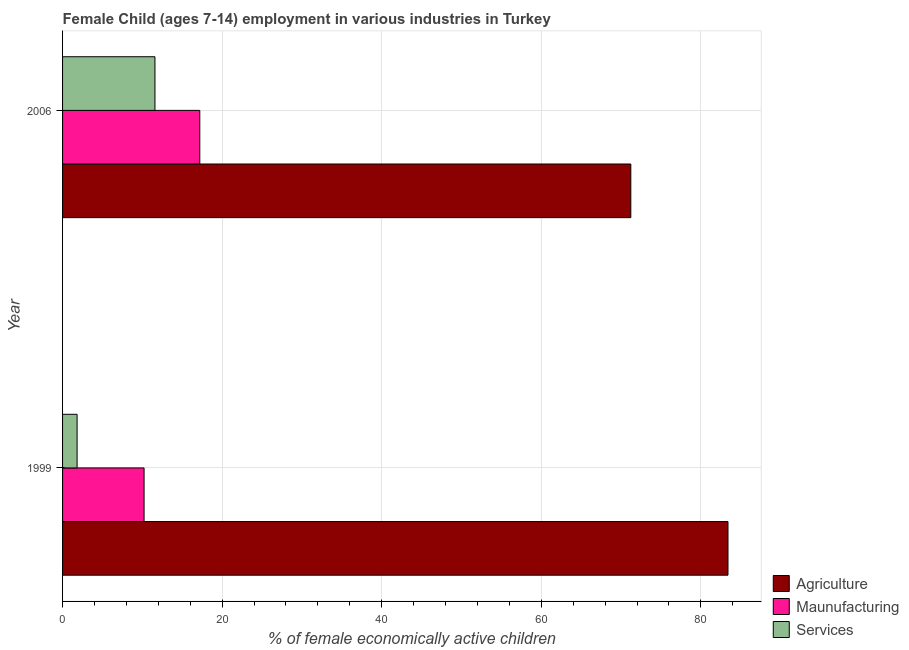How many groups of bars are there?
Provide a short and direct response. 2. Are the number of bars per tick equal to the number of legend labels?
Your answer should be very brief. Yes. In how many cases, is the number of bars for a given year not equal to the number of legend labels?
Your response must be concise. 0. What is the percentage of economically active children in manufacturing in 2006?
Offer a very short reply. 17.2. Across all years, what is the maximum percentage of economically active children in manufacturing?
Make the answer very short. 17.2. Across all years, what is the minimum percentage of economically active children in manufacturing?
Your answer should be compact. 10.22. In which year was the percentage of economically active children in services maximum?
Provide a succinct answer. 2006. In which year was the percentage of economically active children in services minimum?
Make the answer very short. 1999. What is the total percentage of economically active children in agriculture in the graph?
Give a very brief answer. 154.62. What is the difference between the percentage of economically active children in services in 1999 and that in 2006?
Your answer should be very brief. -9.76. What is the difference between the percentage of economically active children in services in 2006 and the percentage of economically active children in agriculture in 1999?
Your answer should be compact. -71.82. What is the average percentage of economically active children in agriculture per year?
Your response must be concise. 77.31. In the year 1999, what is the difference between the percentage of economically active children in services and percentage of economically active children in manufacturing?
Your answer should be very brief. -8.39. In how many years, is the percentage of economically active children in agriculture greater than 40 %?
Give a very brief answer. 2. What is the ratio of the percentage of economically active children in services in 1999 to that in 2006?
Your response must be concise. 0.16. Is the percentage of economically active children in agriculture in 1999 less than that in 2006?
Offer a very short reply. No. Is the difference between the percentage of economically active children in agriculture in 1999 and 2006 greater than the difference between the percentage of economically active children in manufacturing in 1999 and 2006?
Ensure brevity in your answer.  Yes. What does the 1st bar from the top in 1999 represents?
Offer a terse response. Services. What does the 1st bar from the bottom in 1999 represents?
Offer a terse response. Agriculture. How many bars are there?
Ensure brevity in your answer.  6. Are all the bars in the graph horizontal?
Your answer should be compact. Yes. What is the difference between two consecutive major ticks on the X-axis?
Provide a succinct answer. 20. Where does the legend appear in the graph?
Provide a succinct answer. Bottom right. How are the legend labels stacked?
Provide a succinct answer. Vertical. What is the title of the graph?
Provide a succinct answer. Female Child (ages 7-14) employment in various industries in Turkey. What is the label or title of the X-axis?
Give a very brief answer. % of female economically active children. What is the % of female economically active children in Agriculture in 1999?
Ensure brevity in your answer.  83.4. What is the % of female economically active children in Maunufacturing in 1999?
Keep it short and to the point. 10.22. What is the % of female economically active children of Services in 1999?
Offer a very short reply. 1.82. What is the % of female economically active children in Agriculture in 2006?
Give a very brief answer. 71.22. What is the % of female economically active children in Services in 2006?
Your answer should be compact. 11.58. Across all years, what is the maximum % of female economically active children of Agriculture?
Your response must be concise. 83.4. Across all years, what is the maximum % of female economically active children of Services?
Keep it short and to the point. 11.58. Across all years, what is the minimum % of female economically active children of Agriculture?
Your answer should be compact. 71.22. Across all years, what is the minimum % of female economically active children in Maunufacturing?
Provide a succinct answer. 10.22. Across all years, what is the minimum % of female economically active children of Services?
Offer a terse response. 1.82. What is the total % of female economically active children of Agriculture in the graph?
Your answer should be compact. 154.62. What is the total % of female economically active children of Maunufacturing in the graph?
Offer a terse response. 27.42. What is the total % of female economically active children in Services in the graph?
Keep it short and to the point. 13.4. What is the difference between the % of female economically active children of Agriculture in 1999 and that in 2006?
Ensure brevity in your answer.  12.18. What is the difference between the % of female economically active children in Maunufacturing in 1999 and that in 2006?
Provide a succinct answer. -6.98. What is the difference between the % of female economically active children of Services in 1999 and that in 2006?
Keep it short and to the point. -9.76. What is the difference between the % of female economically active children of Agriculture in 1999 and the % of female economically active children of Maunufacturing in 2006?
Your answer should be very brief. 66.2. What is the difference between the % of female economically active children in Agriculture in 1999 and the % of female economically active children in Services in 2006?
Give a very brief answer. 71.82. What is the difference between the % of female economically active children of Maunufacturing in 1999 and the % of female economically active children of Services in 2006?
Your answer should be very brief. -1.36. What is the average % of female economically active children of Agriculture per year?
Your response must be concise. 77.31. What is the average % of female economically active children in Maunufacturing per year?
Give a very brief answer. 13.71. What is the average % of female economically active children in Services per year?
Your answer should be very brief. 6.7. In the year 1999, what is the difference between the % of female economically active children of Agriculture and % of female economically active children of Maunufacturing?
Offer a very short reply. 73.18. In the year 1999, what is the difference between the % of female economically active children in Agriculture and % of female economically active children in Services?
Offer a very short reply. 81.58. In the year 1999, what is the difference between the % of female economically active children of Maunufacturing and % of female economically active children of Services?
Ensure brevity in your answer.  8.39. In the year 2006, what is the difference between the % of female economically active children in Agriculture and % of female economically active children in Maunufacturing?
Make the answer very short. 54.02. In the year 2006, what is the difference between the % of female economically active children of Agriculture and % of female economically active children of Services?
Provide a succinct answer. 59.64. In the year 2006, what is the difference between the % of female economically active children in Maunufacturing and % of female economically active children in Services?
Provide a short and direct response. 5.62. What is the ratio of the % of female economically active children in Agriculture in 1999 to that in 2006?
Your response must be concise. 1.17. What is the ratio of the % of female economically active children in Maunufacturing in 1999 to that in 2006?
Offer a terse response. 0.59. What is the ratio of the % of female economically active children of Services in 1999 to that in 2006?
Ensure brevity in your answer.  0.16. What is the difference between the highest and the second highest % of female economically active children of Agriculture?
Offer a terse response. 12.18. What is the difference between the highest and the second highest % of female economically active children in Maunufacturing?
Offer a very short reply. 6.98. What is the difference between the highest and the second highest % of female economically active children in Services?
Your answer should be compact. 9.76. What is the difference between the highest and the lowest % of female economically active children in Agriculture?
Make the answer very short. 12.18. What is the difference between the highest and the lowest % of female economically active children of Maunufacturing?
Offer a terse response. 6.98. What is the difference between the highest and the lowest % of female economically active children of Services?
Provide a short and direct response. 9.76. 